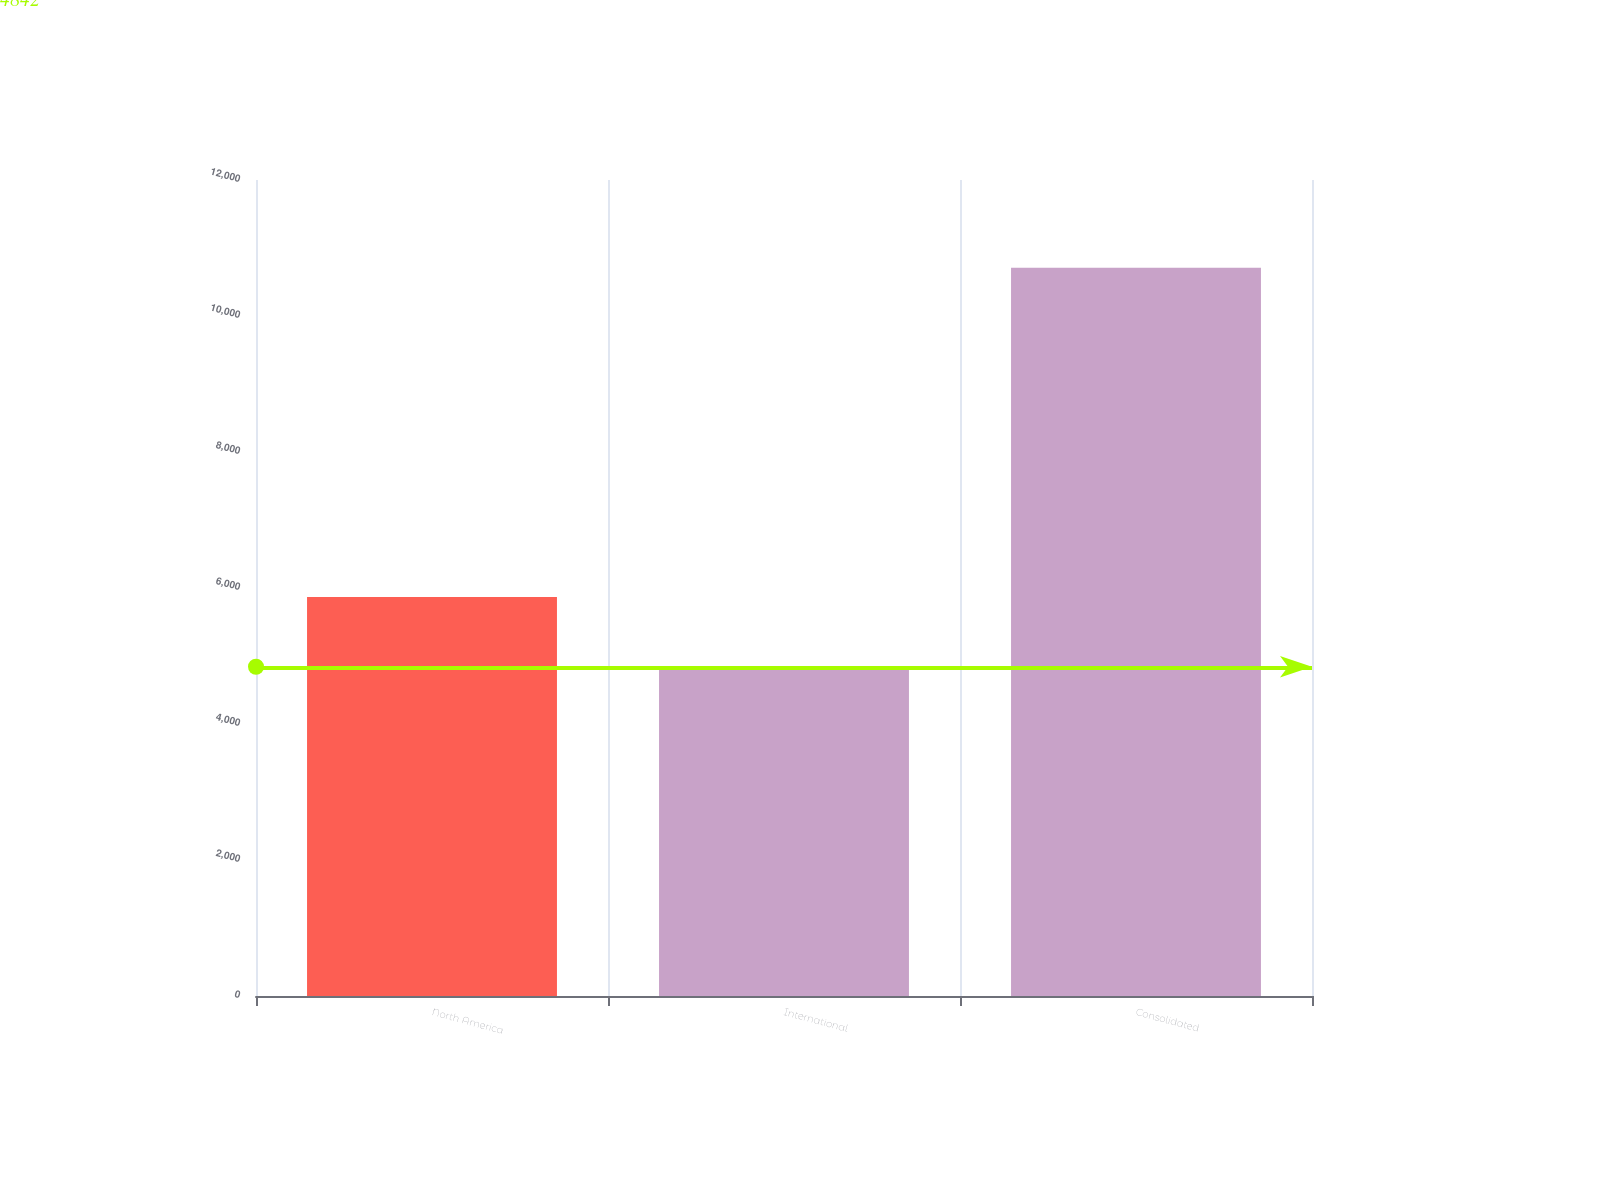Convert chart. <chart><loc_0><loc_0><loc_500><loc_500><bar_chart><fcel>North America<fcel>International<fcel>Consolidated<nl><fcel>5869<fcel>4842<fcel>10711<nl></chart> 